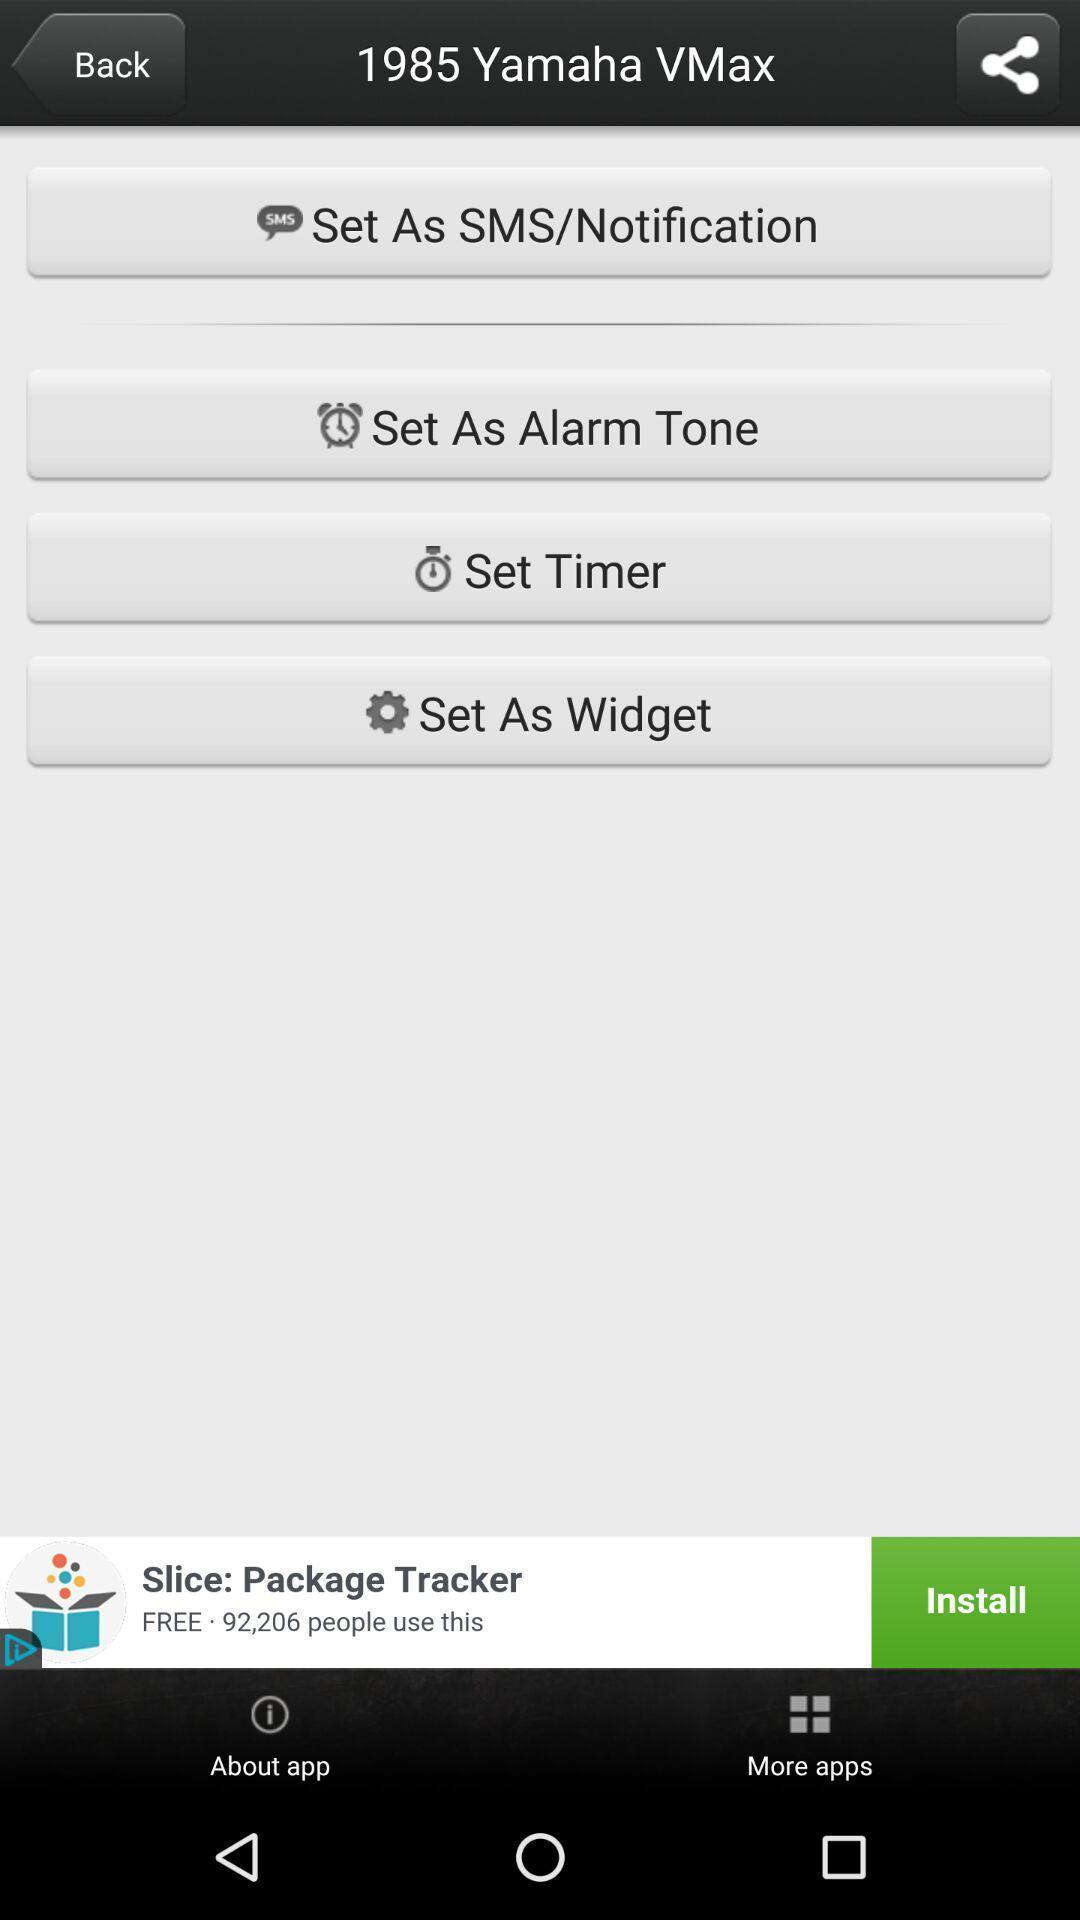Please provide a description for this image. Screen shows options. 